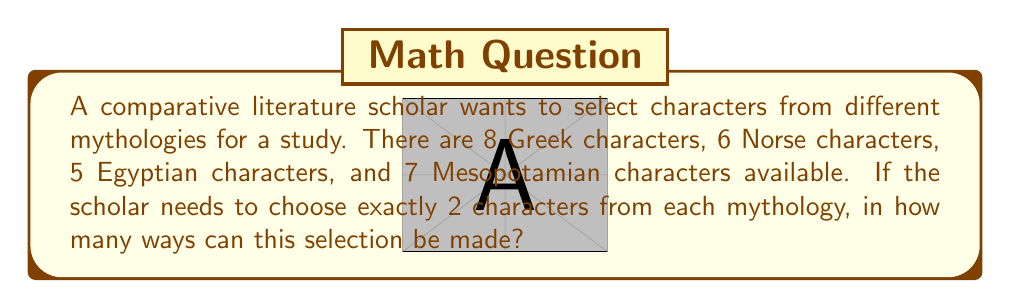Help me with this question. Let's approach this step-by-step:

1) We need to select 2 characters from each mythology. This is a combination problem for each mythology.

2) For Greek mythology:
   We need to choose 2 out of 8 characters.
   This can be done in $\binom{8}{2}$ ways.

3) For Norse mythology:
   We need to choose 2 out of 6 characters.
   This can be done in $\binom{6}{2}$ ways.

4) For Egyptian mythology:
   We need to choose 2 out of 5 characters.
   This can be done in $\binom{5}{2}$ ways.

5) For Mesopotamian mythology:
   We need to choose 2 out of 7 characters.
   This can be done in $\binom{7}{2}$ ways.

6) Now, let's calculate each combination:

   $\binom{8}{2} = \frac{8!}{2!(8-2)!} = \frac{8 \cdot 7}{2 \cdot 1} = 28$

   $\binom{6}{2} = \frac{6!}{2!(6-2)!} = \frac{6 \cdot 5}{2 \cdot 1} = 15$

   $\binom{5}{2} = \frac{5!}{2!(5-2)!} = \frac{5 \cdot 4}{2 \cdot 1} = 10$

   $\binom{7}{2} = \frac{7!}{2!(7-2)!} = \frac{7 \cdot 6}{2 \cdot 1} = 21$

7) According to the multiplication principle, if we have to make independent choices, we multiply the number of ways each choice can be made.

8) Therefore, the total number of ways to select the characters is:

   $28 \cdot 15 \cdot 10 \cdot 21 = 88,200$
Answer: 88,200 